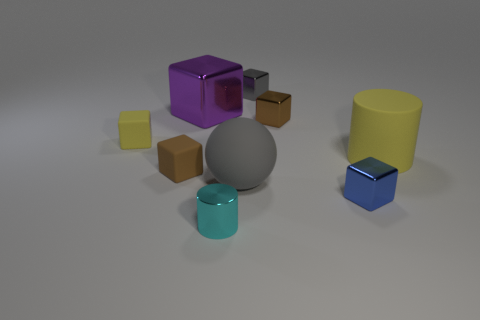How many objects are there in total, and can you name their shapes? There are nine objects in total. Starting from the left, there's a small yellow cube, a larger brown cube, a medium-sized gray sphere, a small brown cube, and a large cylindrical yellow container. In the front row, there is a small light blue cube, a medium-sized teal cylinder, a small purple cube, and a large purple cube. 